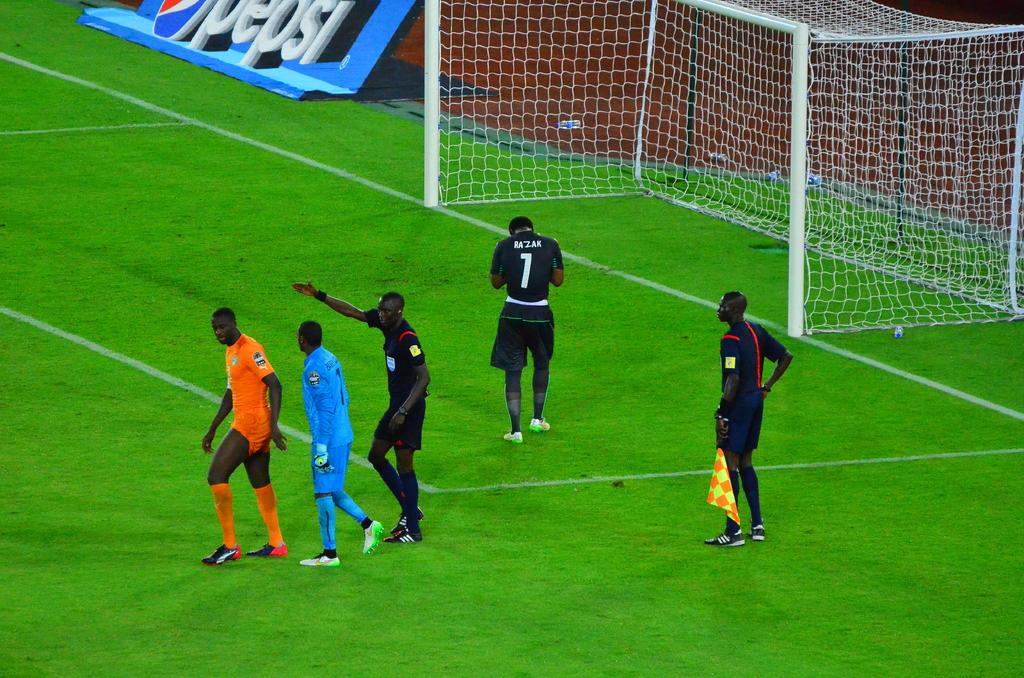<image>
Provide a brief description of the given image. A group of men on a soccer field and one has the number 1 on his jersey. 